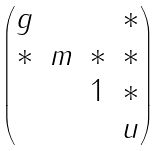<formula> <loc_0><loc_0><loc_500><loc_500>\begin{pmatrix} g & & & * \\ * & m & * & * \\ & & 1 & * \\ & & & u \end{pmatrix}</formula> 